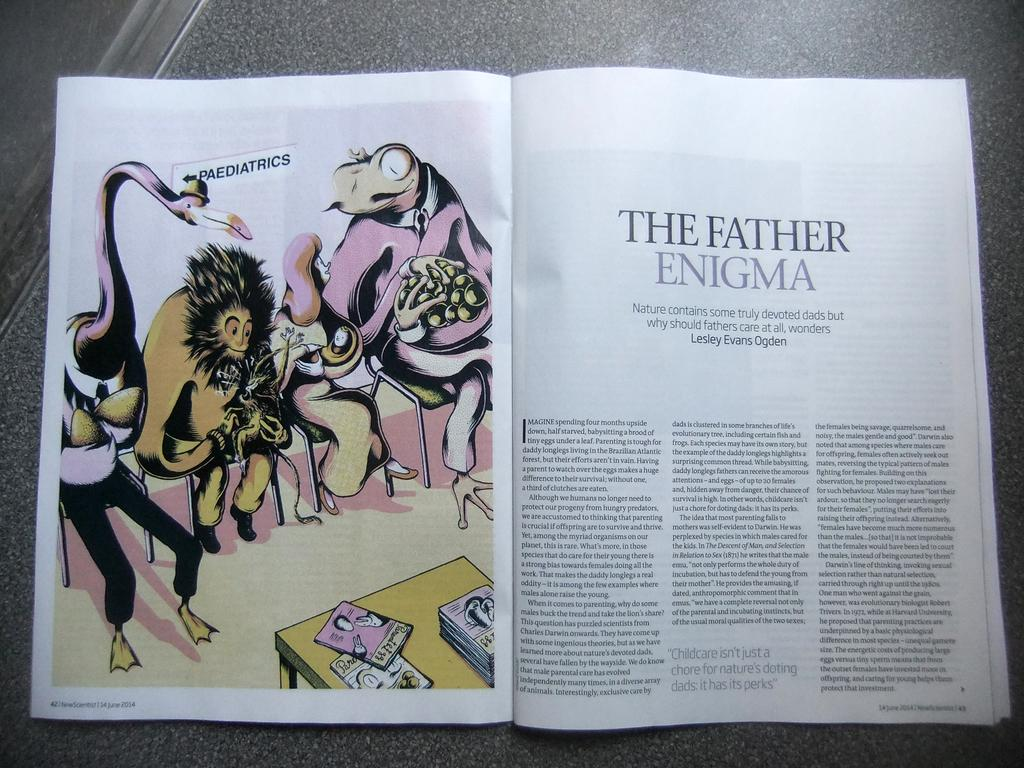<image>
Relay a brief, clear account of the picture shown. A chapter in a New Scientist magazine called "The Father Enigma" 